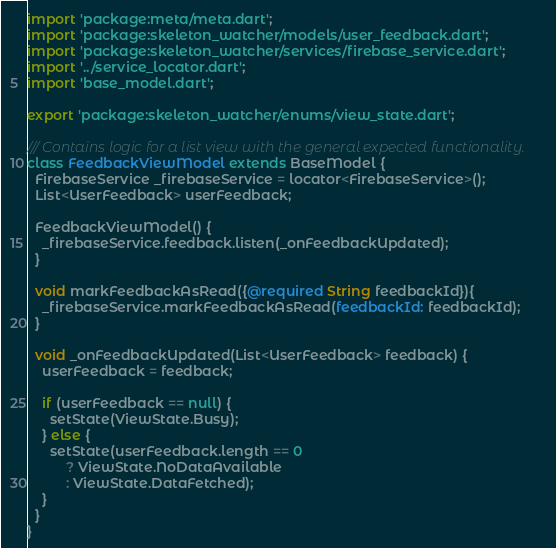Convert code to text. <code><loc_0><loc_0><loc_500><loc_500><_Dart_>import 'package:meta/meta.dart';
import 'package:skeleton_watcher/models/user_feedback.dart';
import 'package:skeleton_watcher/services/firebase_service.dart';
import '../service_locator.dart';
import 'base_model.dart';

export 'package:skeleton_watcher/enums/view_state.dart';

/// Contains logic for a list view with the general expected functionality.
class FeedbackViewModel extends BaseModel {
  FirebaseService _firebaseService = locator<FirebaseService>();
  List<UserFeedback> userFeedback;

  FeedbackViewModel() {
    _firebaseService.feedback.listen(_onFeedbackUpdated);
  }

  void markFeedbackAsRead({@required String feedbackId}){
    _firebaseService.markFeedbackAsRead(feedbackId: feedbackId);
  }

  void _onFeedbackUpdated(List<UserFeedback> feedback) {
    userFeedback = feedback;

    if (userFeedback == null) {
      setState(ViewState.Busy);
    } else {
      setState(userFeedback.length == 0
          ? ViewState.NoDataAvailable
          : ViewState.DataFetched);
    }
  }
}
</code> 